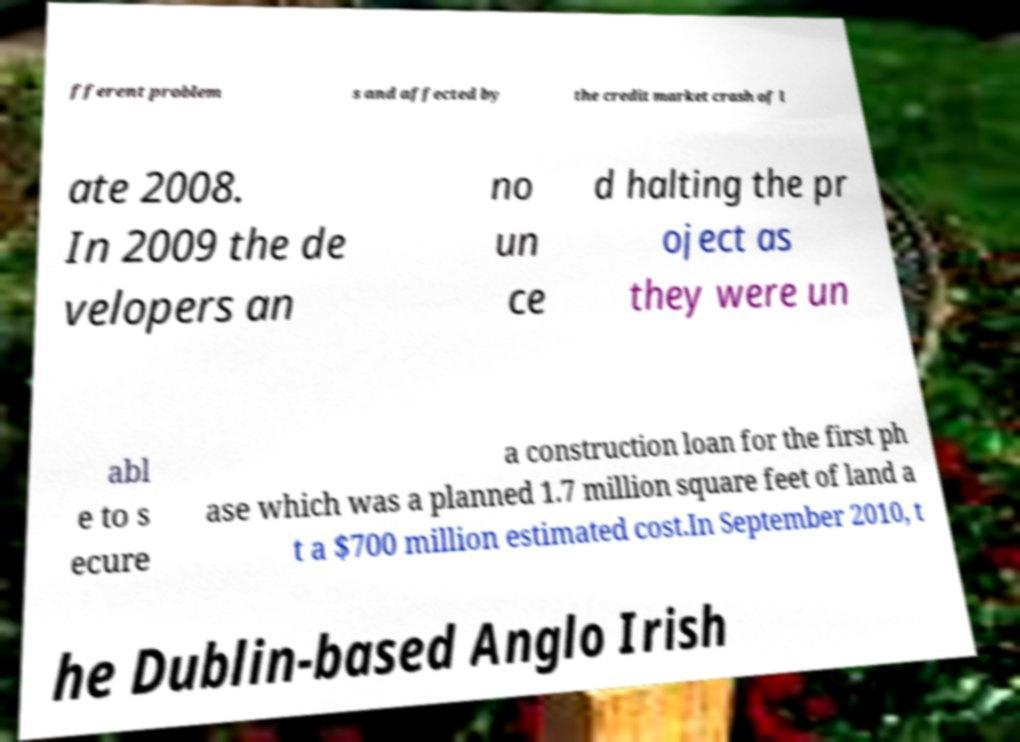I need the written content from this picture converted into text. Can you do that? fferent problem s and affected by the credit market crash of l ate 2008. In 2009 the de velopers an no un ce d halting the pr oject as they were un abl e to s ecure a construction loan for the first ph ase which was a planned 1.7 million square feet of land a t a $700 million estimated cost.In September 2010, t he Dublin-based Anglo Irish 